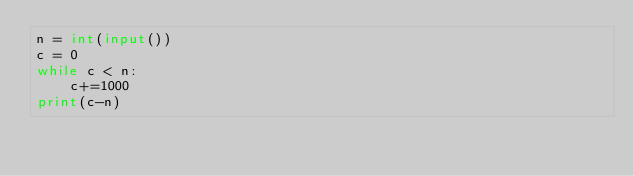<code> <loc_0><loc_0><loc_500><loc_500><_Python_>n = int(input())
c = 0
while c < n:
    c+=1000
print(c-n)</code> 